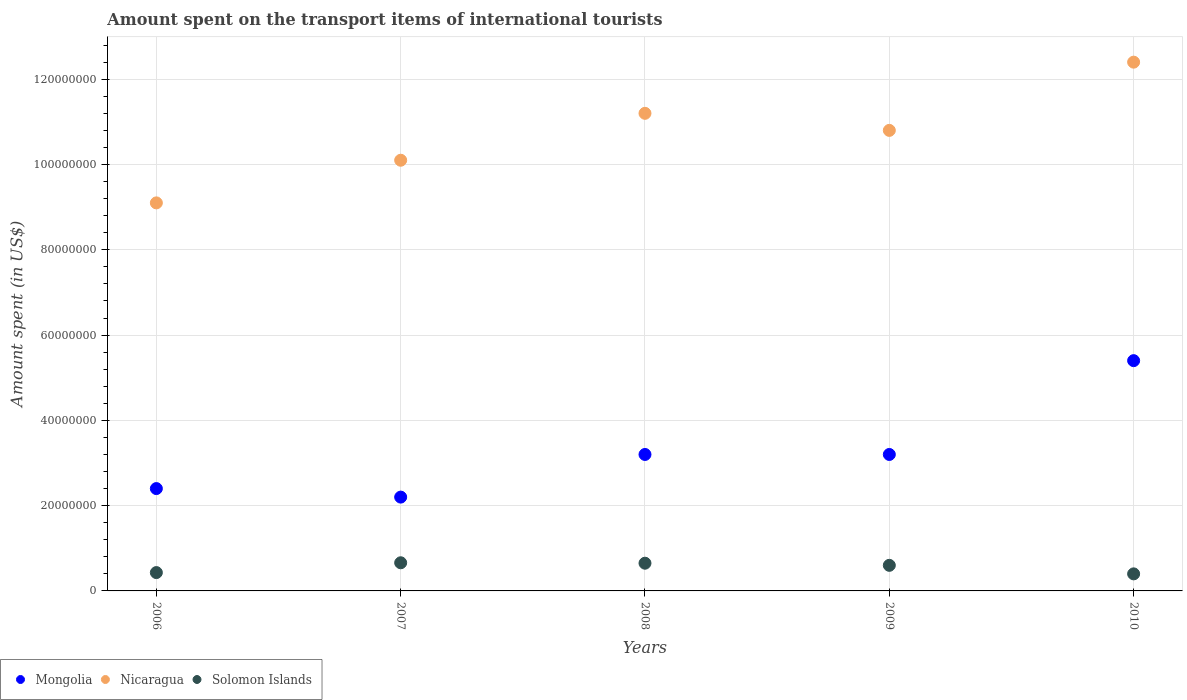How many different coloured dotlines are there?
Your response must be concise. 3. What is the amount spent on the transport items of international tourists in Solomon Islands in 2009?
Ensure brevity in your answer.  6.00e+06. Across all years, what is the maximum amount spent on the transport items of international tourists in Mongolia?
Your answer should be compact. 5.40e+07. Across all years, what is the minimum amount spent on the transport items of international tourists in Mongolia?
Give a very brief answer. 2.20e+07. In which year was the amount spent on the transport items of international tourists in Mongolia maximum?
Your response must be concise. 2010. What is the total amount spent on the transport items of international tourists in Mongolia in the graph?
Your response must be concise. 1.64e+08. What is the difference between the amount spent on the transport items of international tourists in Solomon Islands in 2009 and that in 2010?
Provide a succinct answer. 2.00e+06. What is the difference between the amount spent on the transport items of international tourists in Mongolia in 2010 and the amount spent on the transport items of international tourists in Nicaragua in 2008?
Offer a very short reply. -5.80e+07. What is the average amount spent on the transport items of international tourists in Mongolia per year?
Offer a very short reply. 3.28e+07. In the year 2009, what is the difference between the amount spent on the transport items of international tourists in Solomon Islands and amount spent on the transport items of international tourists in Nicaragua?
Make the answer very short. -1.02e+08. What is the ratio of the amount spent on the transport items of international tourists in Solomon Islands in 2009 to that in 2010?
Give a very brief answer. 1.5. Is the difference between the amount spent on the transport items of international tourists in Solomon Islands in 2009 and 2010 greater than the difference between the amount spent on the transport items of international tourists in Nicaragua in 2009 and 2010?
Your response must be concise. Yes. What is the difference between the highest and the second highest amount spent on the transport items of international tourists in Solomon Islands?
Ensure brevity in your answer.  1.00e+05. What is the difference between the highest and the lowest amount spent on the transport items of international tourists in Solomon Islands?
Offer a terse response. 2.60e+06. Is it the case that in every year, the sum of the amount spent on the transport items of international tourists in Nicaragua and amount spent on the transport items of international tourists in Solomon Islands  is greater than the amount spent on the transport items of international tourists in Mongolia?
Ensure brevity in your answer.  Yes. Does the amount spent on the transport items of international tourists in Nicaragua monotonically increase over the years?
Offer a very short reply. No. Is the amount spent on the transport items of international tourists in Solomon Islands strictly less than the amount spent on the transport items of international tourists in Mongolia over the years?
Ensure brevity in your answer.  Yes. How many dotlines are there?
Provide a succinct answer. 3. How many years are there in the graph?
Your response must be concise. 5. What is the difference between two consecutive major ticks on the Y-axis?
Your response must be concise. 2.00e+07. Does the graph contain any zero values?
Make the answer very short. No. Where does the legend appear in the graph?
Provide a succinct answer. Bottom left. How many legend labels are there?
Provide a succinct answer. 3. What is the title of the graph?
Give a very brief answer. Amount spent on the transport items of international tourists. Does "St. Lucia" appear as one of the legend labels in the graph?
Offer a very short reply. No. What is the label or title of the X-axis?
Ensure brevity in your answer.  Years. What is the label or title of the Y-axis?
Make the answer very short. Amount spent (in US$). What is the Amount spent (in US$) in Mongolia in 2006?
Ensure brevity in your answer.  2.40e+07. What is the Amount spent (in US$) in Nicaragua in 2006?
Ensure brevity in your answer.  9.10e+07. What is the Amount spent (in US$) of Solomon Islands in 2006?
Give a very brief answer. 4.30e+06. What is the Amount spent (in US$) in Mongolia in 2007?
Your response must be concise. 2.20e+07. What is the Amount spent (in US$) of Nicaragua in 2007?
Provide a succinct answer. 1.01e+08. What is the Amount spent (in US$) of Solomon Islands in 2007?
Provide a succinct answer. 6.60e+06. What is the Amount spent (in US$) of Mongolia in 2008?
Your answer should be compact. 3.20e+07. What is the Amount spent (in US$) of Nicaragua in 2008?
Provide a succinct answer. 1.12e+08. What is the Amount spent (in US$) of Solomon Islands in 2008?
Give a very brief answer. 6.50e+06. What is the Amount spent (in US$) of Mongolia in 2009?
Keep it short and to the point. 3.20e+07. What is the Amount spent (in US$) in Nicaragua in 2009?
Your answer should be very brief. 1.08e+08. What is the Amount spent (in US$) in Solomon Islands in 2009?
Provide a short and direct response. 6.00e+06. What is the Amount spent (in US$) in Mongolia in 2010?
Your response must be concise. 5.40e+07. What is the Amount spent (in US$) of Nicaragua in 2010?
Offer a very short reply. 1.24e+08. What is the Amount spent (in US$) in Solomon Islands in 2010?
Your response must be concise. 4.00e+06. Across all years, what is the maximum Amount spent (in US$) in Mongolia?
Give a very brief answer. 5.40e+07. Across all years, what is the maximum Amount spent (in US$) of Nicaragua?
Offer a very short reply. 1.24e+08. Across all years, what is the maximum Amount spent (in US$) of Solomon Islands?
Your answer should be very brief. 6.60e+06. Across all years, what is the minimum Amount spent (in US$) in Mongolia?
Your answer should be compact. 2.20e+07. Across all years, what is the minimum Amount spent (in US$) in Nicaragua?
Ensure brevity in your answer.  9.10e+07. What is the total Amount spent (in US$) in Mongolia in the graph?
Make the answer very short. 1.64e+08. What is the total Amount spent (in US$) of Nicaragua in the graph?
Offer a very short reply. 5.36e+08. What is the total Amount spent (in US$) in Solomon Islands in the graph?
Your answer should be very brief. 2.74e+07. What is the difference between the Amount spent (in US$) in Nicaragua in 2006 and that in 2007?
Make the answer very short. -1.00e+07. What is the difference between the Amount spent (in US$) of Solomon Islands in 2006 and that in 2007?
Offer a very short reply. -2.30e+06. What is the difference between the Amount spent (in US$) in Mongolia in 2006 and that in 2008?
Your response must be concise. -8.00e+06. What is the difference between the Amount spent (in US$) of Nicaragua in 2006 and that in 2008?
Ensure brevity in your answer.  -2.10e+07. What is the difference between the Amount spent (in US$) in Solomon Islands in 2006 and that in 2008?
Provide a succinct answer. -2.20e+06. What is the difference between the Amount spent (in US$) of Mongolia in 2006 and that in 2009?
Offer a very short reply. -8.00e+06. What is the difference between the Amount spent (in US$) in Nicaragua in 2006 and that in 2009?
Make the answer very short. -1.70e+07. What is the difference between the Amount spent (in US$) in Solomon Islands in 2006 and that in 2009?
Make the answer very short. -1.70e+06. What is the difference between the Amount spent (in US$) in Mongolia in 2006 and that in 2010?
Give a very brief answer. -3.00e+07. What is the difference between the Amount spent (in US$) in Nicaragua in 2006 and that in 2010?
Give a very brief answer. -3.30e+07. What is the difference between the Amount spent (in US$) in Mongolia in 2007 and that in 2008?
Keep it short and to the point. -1.00e+07. What is the difference between the Amount spent (in US$) in Nicaragua in 2007 and that in 2008?
Provide a short and direct response. -1.10e+07. What is the difference between the Amount spent (in US$) of Solomon Islands in 2007 and that in 2008?
Provide a short and direct response. 1.00e+05. What is the difference between the Amount spent (in US$) in Mongolia in 2007 and that in 2009?
Your answer should be compact. -1.00e+07. What is the difference between the Amount spent (in US$) of Nicaragua in 2007 and that in 2009?
Make the answer very short. -7.00e+06. What is the difference between the Amount spent (in US$) in Mongolia in 2007 and that in 2010?
Offer a very short reply. -3.20e+07. What is the difference between the Amount spent (in US$) of Nicaragua in 2007 and that in 2010?
Provide a succinct answer. -2.30e+07. What is the difference between the Amount spent (in US$) of Solomon Islands in 2007 and that in 2010?
Your answer should be very brief. 2.60e+06. What is the difference between the Amount spent (in US$) in Mongolia in 2008 and that in 2009?
Give a very brief answer. 0. What is the difference between the Amount spent (in US$) in Nicaragua in 2008 and that in 2009?
Offer a terse response. 4.00e+06. What is the difference between the Amount spent (in US$) of Mongolia in 2008 and that in 2010?
Your answer should be very brief. -2.20e+07. What is the difference between the Amount spent (in US$) of Nicaragua in 2008 and that in 2010?
Ensure brevity in your answer.  -1.20e+07. What is the difference between the Amount spent (in US$) in Solomon Islands in 2008 and that in 2010?
Make the answer very short. 2.50e+06. What is the difference between the Amount spent (in US$) of Mongolia in 2009 and that in 2010?
Make the answer very short. -2.20e+07. What is the difference between the Amount spent (in US$) of Nicaragua in 2009 and that in 2010?
Offer a terse response. -1.60e+07. What is the difference between the Amount spent (in US$) of Solomon Islands in 2009 and that in 2010?
Provide a short and direct response. 2.00e+06. What is the difference between the Amount spent (in US$) of Mongolia in 2006 and the Amount spent (in US$) of Nicaragua in 2007?
Your answer should be very brief. -7.70e+07. What is the difference between the Amount spent (in US$) of Mongolia in 2006 and the Amount spent (in US$) of Solomon Islands in 2007?
Ensure brevity in your answer.  1.74e+07. What is the difference between the Amount spent (in US$) of Nicaragua in 2006 and the Amount spent (in US$) of Solomon Islands in 2007?
Your answer should be compact. 8.44e+07. What is the difference between the Amount spent (in US$) in Mongolia in 2006 and the Amount spent (in US$) in Nicaragua in 2008?
Your answer should be compact. -8.80e+07. What is the difference between the Amount spent (in US$) of Mongolia in 2006 and the Amount spent (in US$) of Solomon Islands in 2008?
Ensure brevity in your answer.  1.75e+07. What is the difference between the Amount spent (in US$) in Nicaragua in 2006 and the Amount spent (in US$) in Solomon Islands in 2008?
Your answer should be compact. 8.45e+07. What is the difference between the Amount spent (in US$) in Mongolia in 2006 and the Amount spent (in US$) in Nicaragua in 2009?
Give a very brief answer. -8.40e+07. What is the difference between the Amount spent (in US$) of Mongolia in 2006 and the Amount spent (in US$) of Solomon Islands in 2009?
Offer a very short reply. 1.80e+07. What is the difference between the Amount spent (in US$) of Nicaragua in 2006 and the Amount spent (in US$) of Solomon Islands in 2009?
Keep it short and to the point. 8.50e+07. What is the difference between the Amount spent (in US$) of Mongolia in 2006 and the Amount spent (in US$) of Nicaragua in 2010?
Make the answer very short. -1.00e+08. What is the difference between the Amount spent (in US$) of Mongolia in 2006 and the Amount spent (in US$) of Solomon Islands in 2010?
Provide a succinct answer. 2.00e+07. What is the difference between the Amount spent (in US$) in Nicaragua in 2006 and the Amount spent (in US$) in Solomon Islands in 2010?
Offer a terse response. 8.70e+07. What is the difference between the Amount spent (in US$) in Mongolia in 2007 and the Amount spent (in US$) in Nicaragua in 2008?
Provide a succinct answer. -9.00e+07. What is the difference between the Amount spent (in US$) in Mongolia in 2007 and the Amount spent (in US$) in Solomon Islands in 2008?
Keep it short and to the point. 1.55e+07. What is the difference between the Amount spent (in US$) of Nicaragua in 2007 and the Amount spent (in US$) of Solomon Islands in 2008?
Give a very brief answer. 9.45e+07. What is the difference between the Amount spent (in US$) of Mongolia in 2007 and the Amount spent (in US$) of Nicaragua in 2009?
Your answer should be very brief. -8.60e+07. What is the difference between the Amount spent (in US$) of Mongolia in 2007 and the Amount spent (in US$) of Solomon Islands in 2009?
Make the answer very short. 1.60e+07. What is the difference between the Amount spent (in US$) in Nicaragua in 2007 and the Amount spent (in US$) in Solomon Islands in 2009?
Your response must be concise. 9.50e+07. What is the difference between the Amount spent (in US$) in Mongolia in 2007 and the Amount spent (in US$) in Nicaragua in 2010?
Make the answer very short. -1.02e+08. What is the difference between the Amount spent (in US$) of Mongolia in 2007 and the Amount spent (in US$) of Solomon Islands in 2010?
Keep it short and to the point. 1.80e+07. What is the difference between the Amount spent (in US$) of Nicaragua in 2007 and the Amount spent (in US$) of Solomon Islands in 2010?
Keep it short and to the point. 9.70e+07. What is the difference between the Amount spent (in US$) in Mongolia in 2008 and the Amount spent (in US$) in Nicaragua in 2009?
Give a very brief answer. -7.60e+07. What is the difference between the Amount spent (in US$) in Mongolia in 2008 and the Amount spent (in US$) in Solomon Islands in 2009?
Make the answer very short. 2.60e+07. What is the difference between the Amount spent (in US$) in Nicaragua in 2008 and the Amount spent (in US$) in Solomon Islands in 2009?
Make the answer very short. 1.06e+08. What is the difference between the Amount spent (in US$) of Mongolia in 2008 and the Amount spent (in US$) of Nicaragua in 2010?
Make the answer very short. -9.20e+07. What is the difference between the Amount spent (in US$) of Mongolia in 2008 and the Amount spent (in US$) of Solomon Islands in 2010?
Provide a succinct answer. 2.80e+07. What is the difference between the Amount spent (in US$) in Nicaragua in 2008 and the Amount spent (in US$) in Solomon Islands in 2010?
Give a very brief answer. 1.08e+08. What is the difference between the Amount spent (in US$) in Mongolia in 2009 and the Amount spent (in US$) in Nicaragua in 2010?
Keep it short and to the point. -9.20e+07. What is the difference between the Amount spent (in US$) of Mongolia in 2009 and the Amount spent (in US$) of Solomon Islands in 2010?
Provide a short and direct response. 2.80e+07. What is the difference between the Amount spent (in US$) in Nicaragua in 2009 and the Amount spent (in US$) in Solomon Islands in 2010?
Keep it short and to the point. 1.04e+08. What is the average Amount spent (in US$) of Mongolia per year?
Ensure brevity in your answer.  3.28e+07. What is the average Amount spent (in US$) in Nicaragua per year?
Your answer should be very brief. 1.07e+08. What is the average Amount spent (in US$) in Solomon Islands per year?
Keep it short and to the point. 5.48e+06. In the year 2006, what is the difference between the Amount spent (in US$) of Mongolia and Amount spent (in US$) of Nicaragua?
Your answer should be compact. -6.70e+07. In the year 2006, what is the difference between the Amount spent (in US$) in Mongolia and Amount spent (in US$) in Solomon Islands?
Provide a short and direct response. 1.97e+07. In the year 2006, what is the difference between the Amount spent (in US$) of Nicaragua and Amount spent (in US$) of Solomon Islands?
Your answer should be very brief. 8.67e+07. In the year 2007, what is the difference between the Amount spent (in US$) in Mongolia and Amount spent (in US$) in Nicaragua?
Make the answer very short. -7.90e+07. In the year 2007, what is the difference between the Amount spent (in US$) of Mongolia and Amount spent (in US$) of Solomon Islands?
Provide a short and direct response. 1.54e+07. In the year 2007, what is the difference between the Amount spent (in US$) of Nicaragua and Amount spent (in US$) of Solomon Islands?
Give a very brief answer. 9.44e+07. In the year 2008, what is the difference between the Amount spent (in US$) of Mongolia and Amount spent (in US$) of Nicaragua?
Keep it short and to the point. -8.00e+07. In the year 2008, what is the difference between the Amount spent (in US$) in Mongolia and Amount spent (in US$) in Solomon Islands?
Give a very brief answer. 2.55e+07. In the year 2008, what is the difference between the Amount spent (in US$) in Nicaragua and Amount spent (in US$) in Solomon Islands?
Your answer should be compact. 1.06e+08. In the year 2009, what is the difference between the Amount spent (in US$) of Mongolia and Amount spent (in US$) of Nicaragua?
Make the answer very short. -7.60e+07. In the year 2009, what is the difference between the Amount spent (in US$) in Mongolia and Amount spent (in US$) in Solomon Islands?
Offer a terse response. 2.60e+07. In the year 2009, what is the difference between the Amount spent (in US$) of Nicaragua and Amount spent (in US$) of Solomon Islands?
Provide a short and direct response. 1.02e+08. In the year 2010, what is the difference between the Amount spent (in US$) in Mongolia and Amount spent (in US$) in Nicaragua?
Make the answer very short. -7.00e+07. In the year 2010, what is the difference between the Amount spent (in US$) in Mongolia and Amount spent (in US$) in Solomon Islands?
Ensure brevity in your answer.  5.00e+07. In the year 2010, what is the difference between the Amount spent (in US$) of Nicaragua and Amount spent (in US$) of Solomon Islands?
Offer a very short reply. 1.20e+08. What is the ratio of the Amount spent (in US$) of Nicaragua in 2006 to that in 2007?
Offer a terse response. 0.9. What is the ratio of the Amount spent (in US$) in Solomon Islands in 2006 to that in 2007?
Your answer should be very brief. 0.65. What is the ratio of the Amount spent (in US$) in Mongolia in 2006 to that in 2008?
Make the answer very short. 0.75. What is the ratio of the Amount spent (in US$) of Nicaragua in 2006 to that in 2008?
Provide a succinct answer. 0.81. What is the ratio of the Amount spent (in US$) of Solomon Islands in 2006 to that in 2008?
Your answer should be very brief. 0.66. What is the ratio of the Amount spent (in US$) of Mongolia in 2006 to that in 2009?
Provide a short and direct response. 0.75. What is the ratio of the Amount spent (in US$) in Nicaragua in 2006 to that in 2009?
Make the answer very short. 0.84. What is the ratio of the Amount spent (in US$) of Solomon Islands in 2006 to that in 2009?
Keep it short and to the point. 0.72. What is the ratio of the Amount spent (in US$) of Mongolia in 2006 to that in 2010?
Your response must be concise. 0.44. What is the ratio of the Amount spent (in US$) of Nicaragua in 2006 to that in 2010?
Keep it short and to the point. 0.73. What is the ratio of the Amount spent (in US$) in Solomon Islands in 2006 to that in 2010?
Ensure brevity in your answer.  1.07. What is the ratio of the Amount spent (in US$) of Mongolia in 2007 to that in 2008?
Provide a succinct answer. 0.69. What is the ratio of the Amount spent (in US$) in Nicaragua in 2007 to that in 2008?
Offer a terse response. 0.9. What is the ratio of the Amount spent (in US$) of Solomon Islands in 2007 to that in 2008?
Your response must be concise. 1.02. What is the ratio of the Amount spent (in US$) of Mongolia in 2007 to that in 2009?
Offer a terse response. 0.69. What is the ratio of the Amount spent (in US$) of Nicaragua in 2007 to that in 2009?
Provide a succinct answer. 0.94. What is the ratio of the Amount spent (in US$) in Mongolia in 2007 to that in 2010?
Keep it short and to the point. 0.41. What is the ratio of the Amount spent (in US$) in Nicaragua in 2007 to that in 2010?
Make the answer very short. 0.81. What is the ratio of the Amount spent (in US$) in Solomon Islands in 2007 to that in 2010?
Keep it short and to the point. 1.65. What is the ratio of the Amount spent (in US$) in Mongolia in 2008 to that in 2009?
Offer a terse response. 1. What is the ratio of the Amount spent (in US$) in Mongolia in 2008 to that in 2010?
Your answer should be compact. 0.59. What is the ratio of the Amount spent (in US$) of Nicaragua in 2008 to that in 2010?
Keep it short and to the point. 0.9. What is the ratio of the Amount spent (in US$) in Solomon Islands in 2008 to that in 2010?
Give a very brief answer. 1.62. What is the ratio of the Amount spent (in US$) in Mongolia in 2009 to that in 2010?
Offer a very short reply. 0.59. What is the ratio of the Amount spent (in US$) in Nicaragua in 2009 to that in 2010?
Offer a terse response. 0.87. What is the ratio of the Amount spent (in US$) of Solomon Islands in 2009 to that in 2010?
Provide a short and direct response. 1.5. What is the difference between the highest and the second highest Amount spent (in US$) of Mongolia?
Give a very brief answer. 2.20e+07. What is the difference between the highest and the lowest Amount spent (in US$) in Mongolia?
Offer a terse response. 3.20e+07. What is the difference between the highest and the lowest Amount spent (in US$) of Nicaragua?
Provide a succinct answer. 3.30e+07. What is the difference between the highest and the lowest Amount spent (in US$) in Solomon Islands?
Provide a short and direct response. 2.60e+06. 